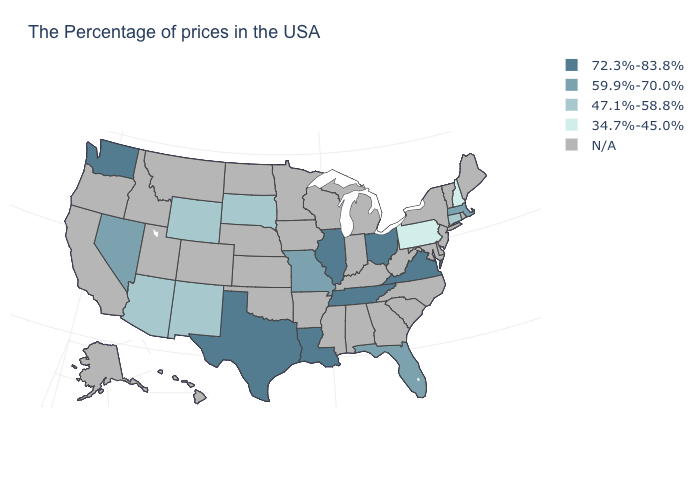Does the map have missing data?
Concise answer only. Yes. Is the legend a continuous bar?
Keep it brief. No. Does the map have missing data?
Quick response, please. Yes. Does Pennsylvania have the lowest value in the USA?
Write a very short answer. Yes. Does the map have missing data?
Short answer required. Yes. What is the highest value in the USA?
Short answer required. 72.3%-83.8%. Does New Hampshire have the lowest value in the USA?
Write a very short answer. Yes. Name the states that have a value in the range 59.9%-70.0%?
Keep it brief. Massachusetts, Florida, Missouri, Nevada. What is the value of Hawaii?
Quick response, please. N/A. How many symbols are there in the legend?
Answer briefly. 5. Among the states that border New Jersey , which have the lowest value?
Answer briefly. Pennsylvania. How many symbols are there in the legend?
Concise answer only. 5. 